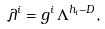Convert formula to latex. <formula><loc_0><loc_0><loc_500><loc_500>\lambda ^ { i } = g ^ { i } \, \Lambda ^ { h _ { i } - D } ,</formula> 